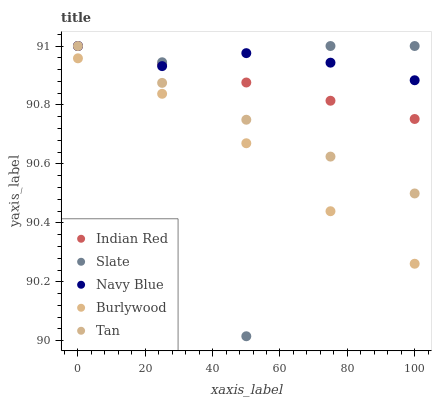Does Burlywood have the minimum area under the curve?
Answer yes or no. Yes. Does Navy Blue have the maximum area under the curve?
Answer yes or no. Yes. Does Slate have the minimum area under the curve?
Answer yes or no. No. Does Slate have the maximum area under the curve?
Answer yes or no. No. Is Tan the smoothest?
Answer yes or no. Yes. Is Slate the roughest?
Answer yes or no. Yes. Is Navy Blue the smoothest?
Answer yes or no. No. Is Navy Blue the roughest?
Answer yes or no. No. Does Slate have the lowest value?
Answer yes or no. Yes. Does Navy Blue have the lowest value?
Answer yes or no. No. Does Indian Red have the highest value?
Answer yes or no. Yes. Is Burlywood less than Indian Red?
Answer yes or no. Yes. Is Tan greater than Burlywood?
Answer yes or no. Yes. Does Navy Blue intersect Indian Red?
Answer yes or no. Yes. Is Navy Blue less than Indian Red?
Answer yes or no. No. Is Navy Blue greater than Indian Red?
Answer yes or no. No. Does Burlywood intersect Indian Red?
Answer yes or no. No. 